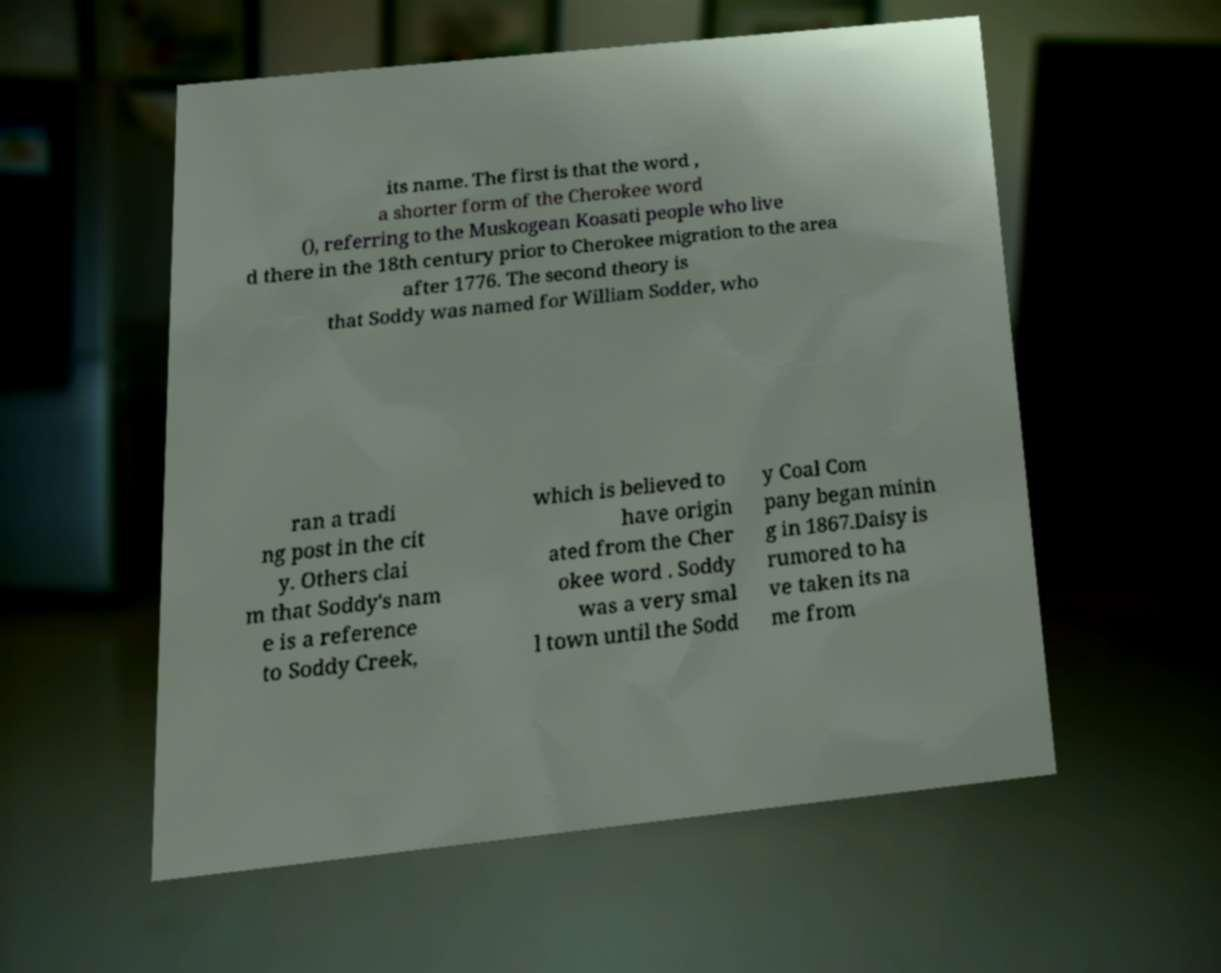There's text embedded in this image that I need extracted. Can you transcribe it verbatim? its name. The first is that the word , a shorter form of the Cherokee word (), referring to the Muskogean Koasati people who live d there in the 18th century prior to Cherokee migration to the area after 1776. The second theory is that Soddy was named for William Sodder, who ran a tradi ng post in the cit y. Others clai m that Soddy's nam e is a reference to Soddy Creek, which is believed to have origin ated from the Cher okee word . Soddy was a very smal l town until the Sodd y Coal Com pany began minin g in 1867.Daisy is rumored to ha ve taken its na me from 